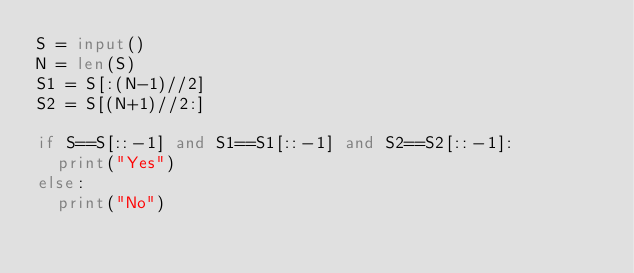Convert code to text. <code><loc_0><loc_0><loc_500><loc_500><_Python_>S = input()
N = len(S)
S1 = S[:(N-1)//2]
S2 = S[(N+1)//2:]

if S==S[::-1] and S1==S1[::-1] and S2==S2[::-1]:
  print("Yes")
else:
  print("No")</code> 